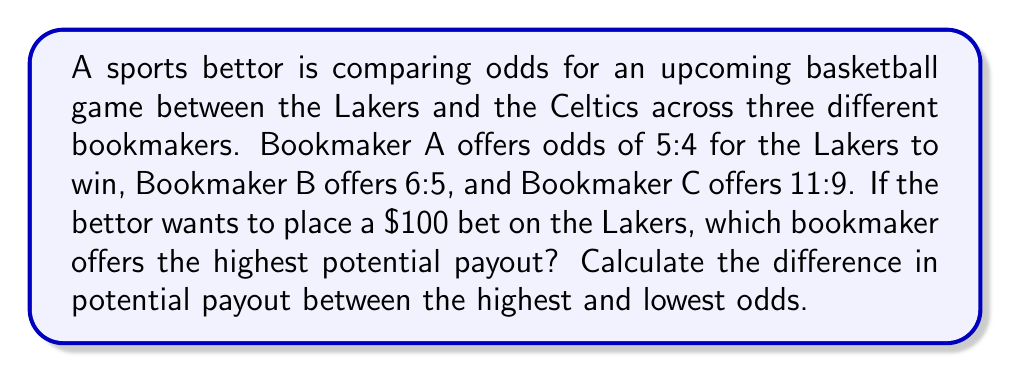What is the answer to this math problem? To solve this problem, we need to:
1. Convert the odds to decimal format
2. Calculate the potential payout for each bookmaker
3. Compare the payouts and find the highest
4. Calculate the difference between the highest and lowest payouts

Step 1: Convert odds to decimal format
For odds in the format X:Y, the decimal odds are calculated as: $\frac{X+Y}{Y}$

Bookmaker A: $\frac{5+4}{4} = \frac{9}{4} = 2.25$
Bookmaker B: $\frac{6+5}{5} = \frac{11}{5} = 2.20$
Bookmaker C: $\frac{11+9}{9} = \frac{20}{9} \approx 2.22$

Step 2: Calculate potential payout for a $100 bet
Payout = Bet × Decimal Odds

Bookmaker A: $100 \times 2.25 = $225$
Bookmaker B: $100 \times 2.20 = $220$
Bookmaker C: $100 \times 2.22 = $222$

Step 3: Compare payouts
Bookmaker A offers the highest payout at $225.

Step 4: Calculate the difference between highest and lowest payouts
Difference = Highest payout - Lowest payout
$225 - $220 = $5$

Therefore, Bookmaker A offers the highest potential payout, and the difference between the highest and lowest payouts is $5.
Answer: Bookmaker A; $5 